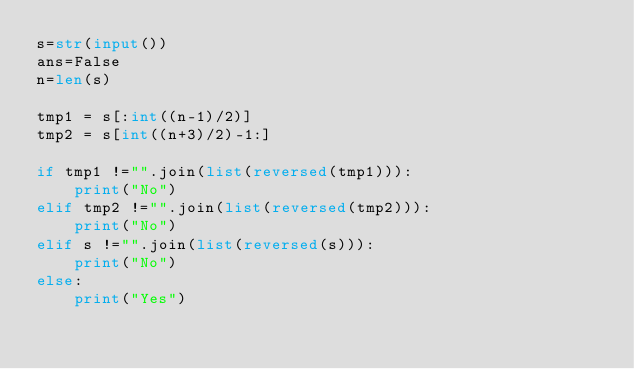<code> <loc_0><loc_0><loc_500><loc_500><_Python_>s=str(input())
ans=False
n=len(s)

tmp1 = s[:int((n-1)/2)]
tmp2 = s[int((n+3)/2)-1:]

if tmp1 !="".join(list(reversed(tmp1))):
    print("No")
elif tmp2 !="".join(list(reversed(tmp2))):
    print("No")
elif s !="".join(list(reversed(s))):
    print("No")
else:
    print("Yes")</code> 